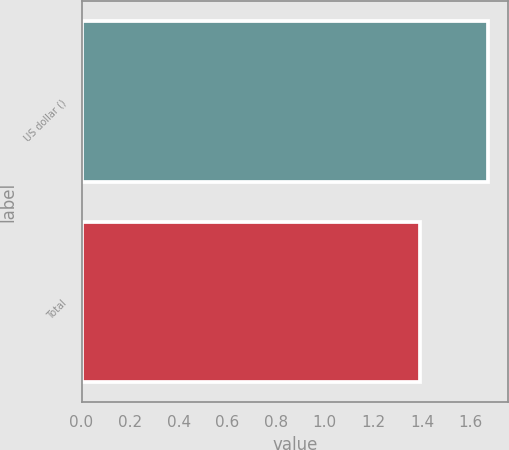<chart> <loc_0><loc_0><loc_500><loc_500><bar_chart><fcel>US dollar ()<fcel>Total<nl><fcel>1.67<fcel>1.39<nl></chart> 